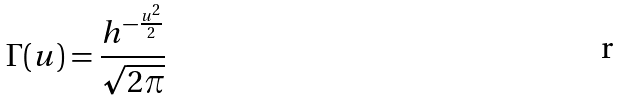<formula> <loc_0><loc_0><loc_500><loc_500>\Gamma ( u ) = \frac { h ^ { - \frac { u ^ { 2 } } { 2 } } } { \sqrt { 2 \pi } }</formula> 